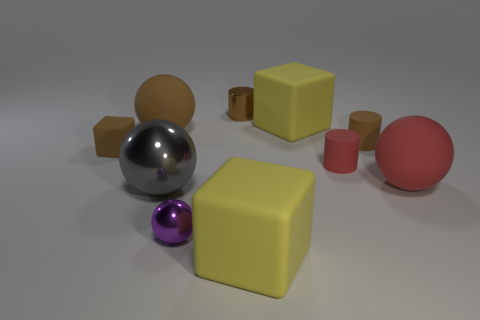Subtract all blue balls. Subtract all green cylinders. How many balls are left? 4 Subtract all cylinders. How many objects are left? 7 Add 2 large gray things. How many large gray things exist? 3 Subtract 1 brown cubes. How many objects are left? 9 Subtract all big spheres. Subtract all brown shiny cylinders. How many objects are left? 6 Add 5 brown blocks. How many brown blocks are left? 6 